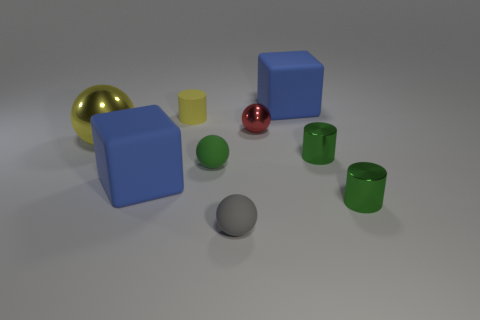What shape is the object that is the same color as the large metal sphere?
Provide a short and direct response. Cylinder. Do the big blue cube that is in front of the red shiny ball and the small gray ball have the same material?
Keep it short and to the point. Yes. There is a ball that is left of the yellow object to the right of the large yellow shiny ball; what is it made of?
Offer a very short reply. Metal. How many large brown metallic things have the same shape as the gray object?
Provide a short and direct response. 0. How big is the yellow matte cylinder that is in front of the big blue rubber object behind the matte cylinder that is right of the big yellow metallic sphere?
Offer a very short reply. Small. How many yellow objects are either large shiny spheres or small cylinders?
Offer a very short reply. 2. Is the shape of the large yellow shiny object behind the small gray sphere the same as  the tiny yellow object?
Provide a succinct answer. No. Is the number of small metal things that are behind the large yellow sphere greater than the number of tiny brown objects?
Provide a short and direct response. Yes. What number of gray metal objects are the same size as the gray rubber sphere?
Your answer should be very brief. 0. What size is the shiny sphere that is the same color as the small matte cylinder?
Offer a very short reply. Large. 